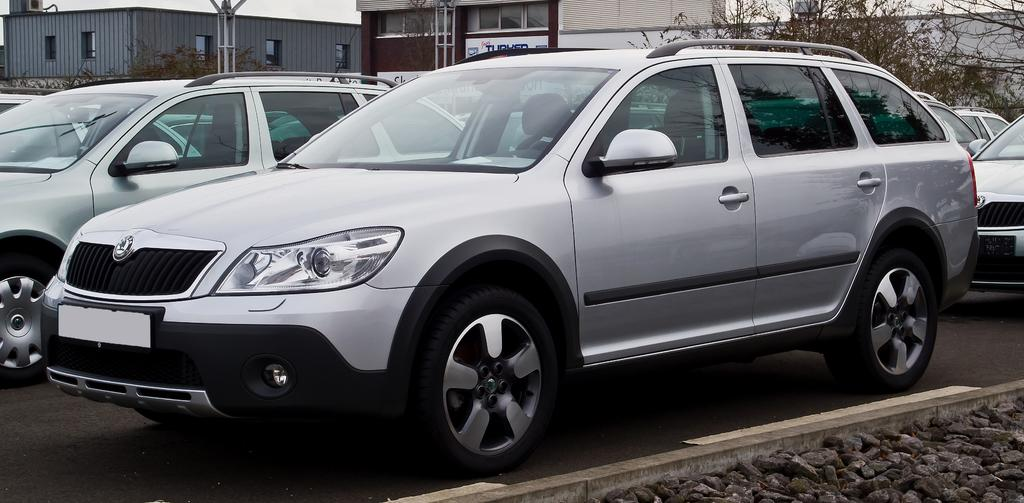What is happening on the road in the image? There are vehicles on the road in the image. What type of objects can be seen on the ground in the image? There are stones visible in the image. What can be seen in the distance in the image? There are buildings, trees, and a pole in the background of the image. How many pies and pizzas are being sold at the store in the image? There is no store or mention of pies and pizzas in the image. What type of expansion is occurring in the image? There is no indication of expansion in the image. 